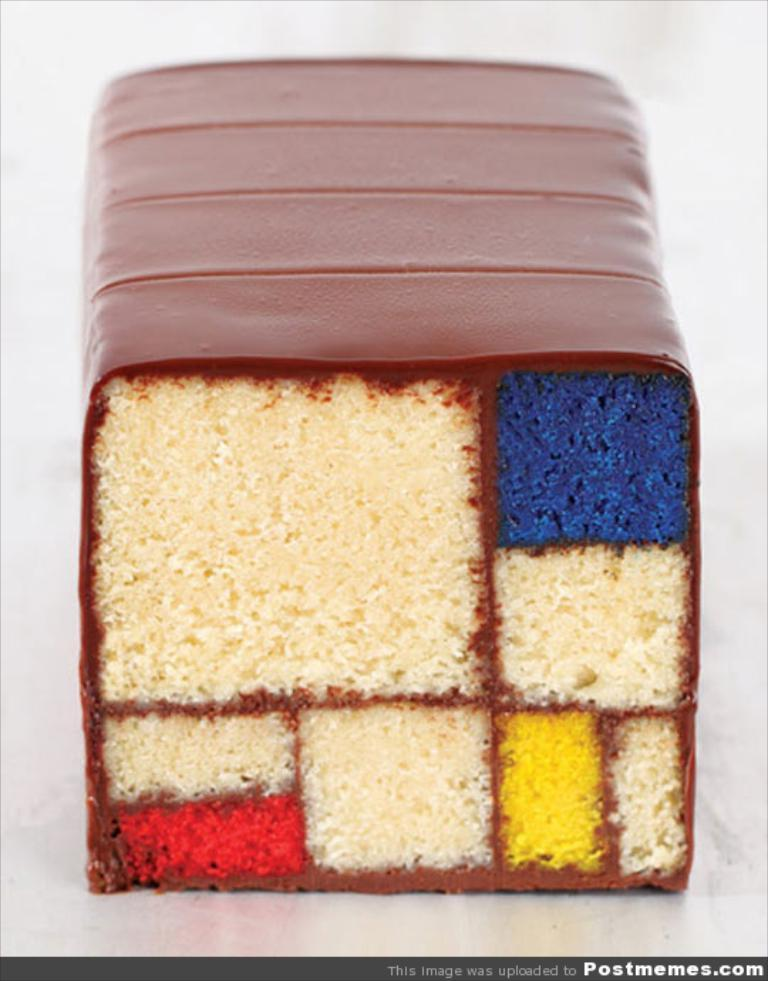What can be seen in the image related to food? There is food in the image. What is written or displayed at the bottom of the image? There is text at the bottom of the image. What color is the background of the image? The background of the image is white. How does the friction affect the food in the image? There is no information about friction in the image, so we cannot determine its effect on the food. What view can be seen from the image? The image does not depict a view; it only shows food and text on a white background. 